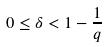Convert formula to latex. <formula><loc_0><loc_0><loc_500><loc_500>0 \leq \delta < 1 - \frac { 1 } { q }</formula> 